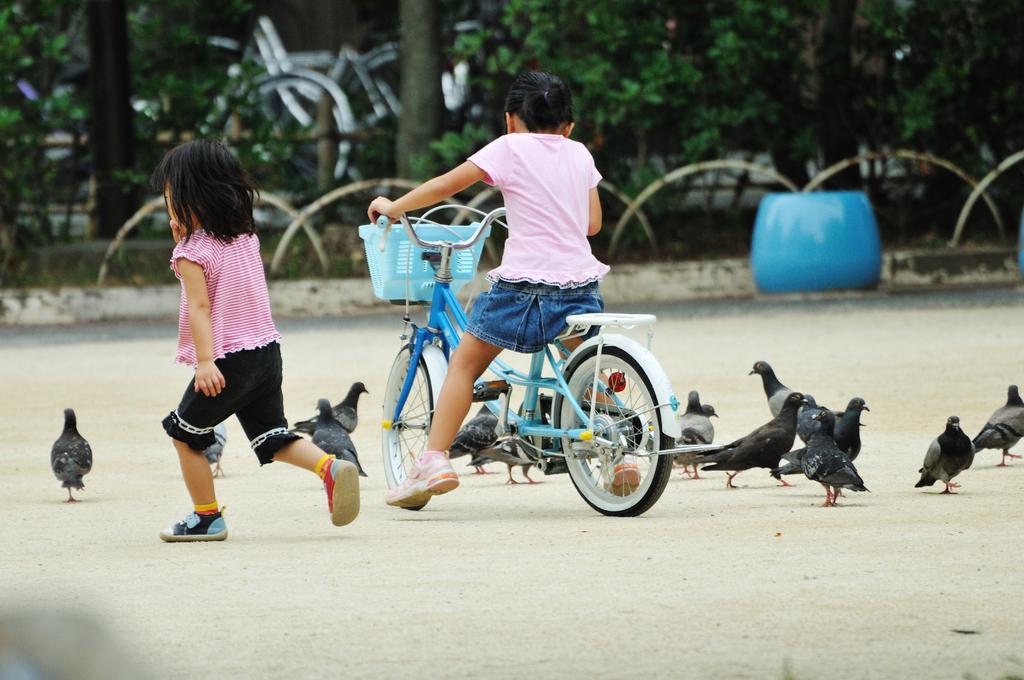In one or two sentences, can you explain what this image depicts? In this picture we can see two children one among them riding the bicycle and in front of them there are some pigeons and some plants and trees. 